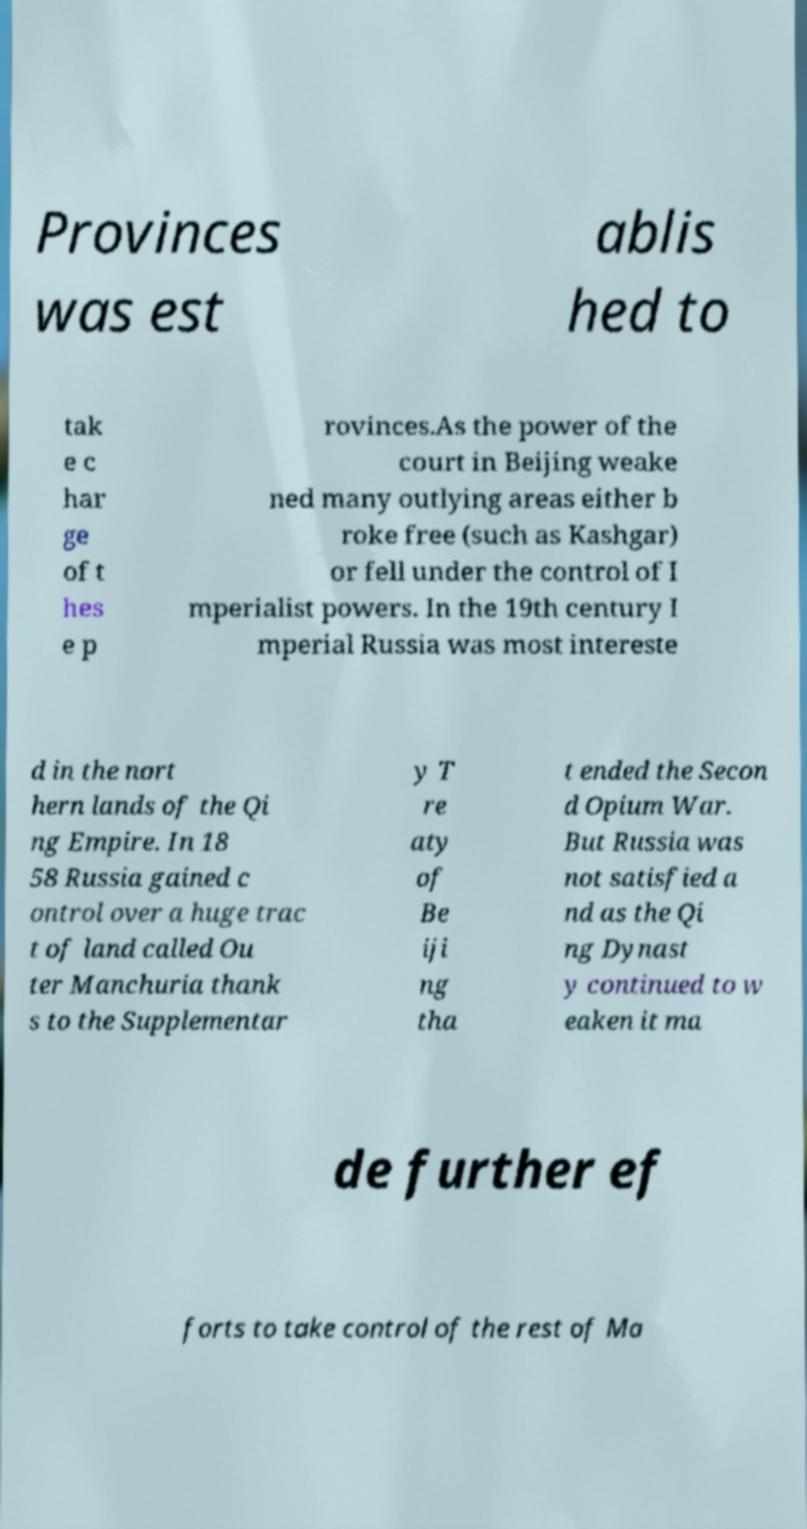Please identify and transcribe the text found in this image. Provinces was est ablis hed to tak e c har ge of t hes e p rovinces.As the power of the court in Beijing weake ned many outlying areas either b roke free (such as Kashgar) or fell under the control of I mperialist powers. In the 19th century I mperial Russia was most intereste d in the nort hern lands of the Qi ng Empire. In 18 58 Russia gained c ontrol over a huge trac t of land called Ou ter Manchuria thank s to the Supplementar y T re aty of Be iji ng tha t ended the Secon d Opium War. But Russia was not satisfied a nd as the Qi ng Dynast y continued to w eaken it ma de further ef forts to take control of the rest of Ma 